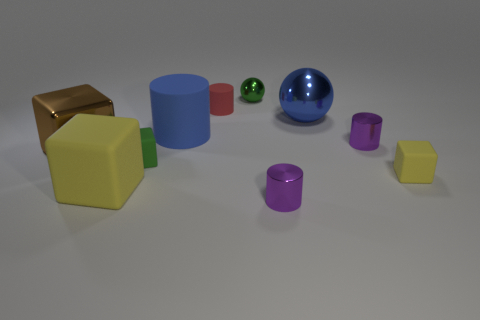Is the material of the red cylinder the same as the green thing on the left side of the large cylinder?
Your response must be concise. Yes. What number of other things are the same shape as the brown object?
Make the answer very short. 3. There is a big metallic ball; is it the same color as the tiny object that is in front of the small yellow object?
Your answer should be very brief. No. There is a small green object on the left side of the metal object that is behind the big blue ball; what shape is it?
Make the answer very short. Cube. What is the size of the matte object that is the same color as the small metal ball?
Offer a terse response. Small. There is a matte object that is in front of the small yellow matte cube; is its shape the same as the blue rubber thing?
Make the answer very short. No. Are there more metal objects on the right side of the red object than green spheres that are in front of the big blue sphere?
Provide a succinct answer. Yes. There is a big cube that is on the right side of the metallic cube; what number of purple cylinders are in front of it?
Your answer should be compact. 1. What material is the cylinder that is the same color as the big sphere?
Ensure brevity in your answer.  Rubber. What number of other objects are there of the same color as the large cylinder?
Your answer should be very brief. 1. 